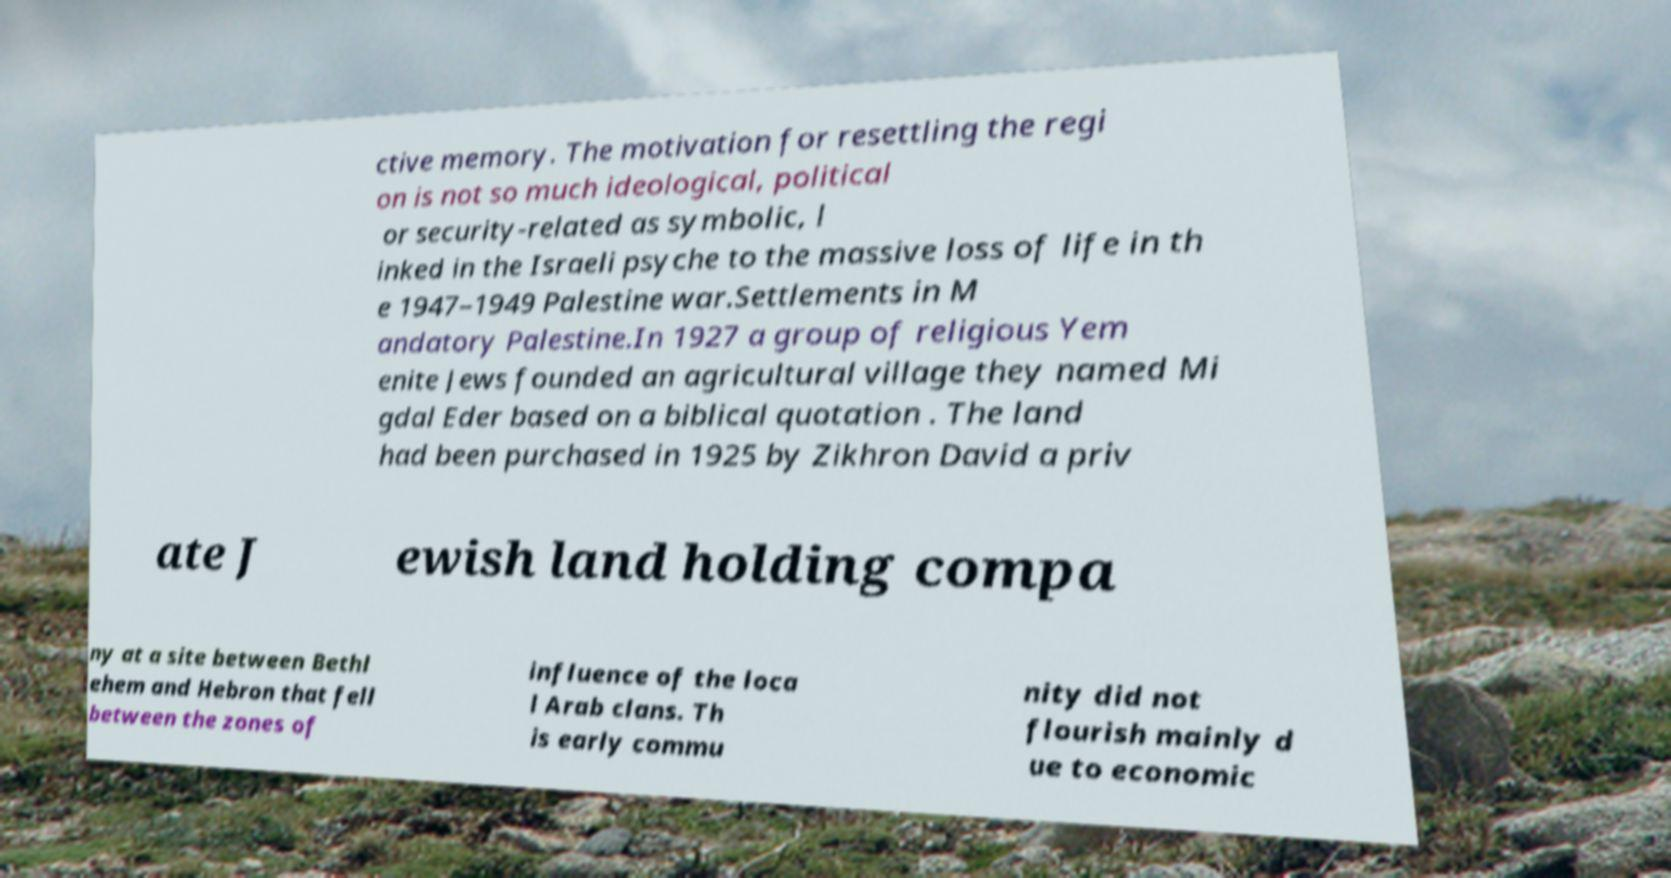For documentation purposes, I need the text within this image transcribed. Could you provide that? ctive memory. The motivation for resettling the regi on is not so much ideological, political or security-related as symbolic, l inked in the Israeli psyche to the massive loss of life in th e 1947–1949 Palestine war.Settlements in M andatory Palestine.In 1927 a group of religious Yem enite Jews founded an agricultural village they named Mi gdal Eder based on a biblical quotation . The land had been purchased in 1925 by Zikhron David a priv ate J ewish land holding compa ny at a site between Bethl ehem and Hebron that fell between the zones of influence of the loca l Arab clans. Th is early commu nity did not flourish mainly d ue to economic 